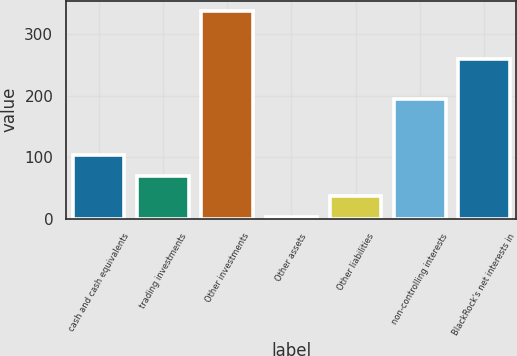<chart> <loc_0><loc_0><loc_500><loc_500><bar_chart><fcel>cash and cash equivalents<fcel>trading investments<fcel>Other investments<fcel>Other assets<fcel>Other liabilities<fcel>non-controlling interests<fcel>BlackRock's net interests in<nl><fcel>103.2<fcel>69.8<fcel>337<fcel>3<fcel>36.4<fcel>195<fcel>260<nl></chart> 